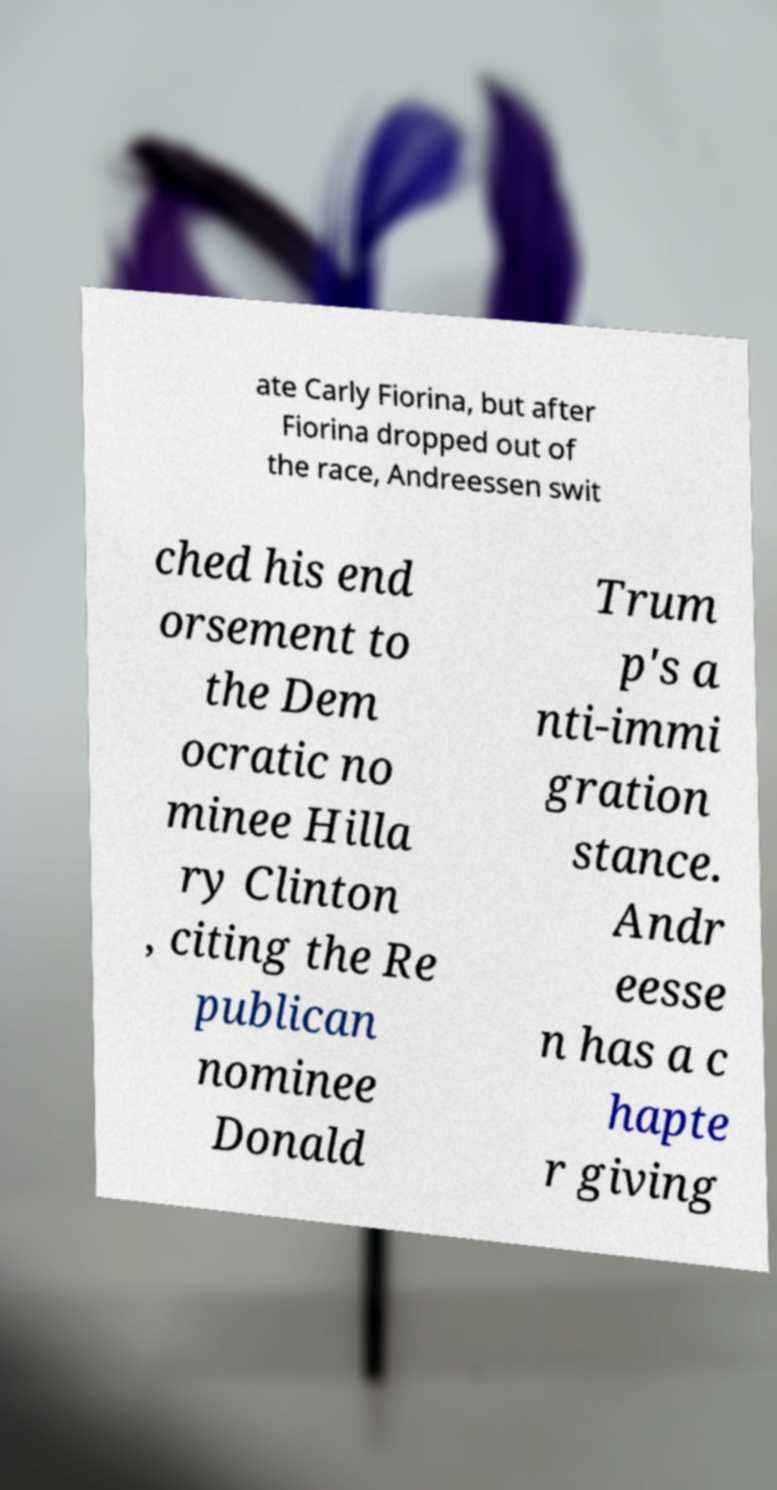Can you read and provide the text displayed in the image?This photo seems to have some interesting text. Can you extract and type it out for me? ate Carly Fiorina, but after Fiorina dropped out of the race, Andreessen swit ched his end orsement to the Dem ocratic no minee Hilla ry Clinton , citing the Re publican nominee Donald Trum p's a nti-immi gration stance. Andr eesse n has a c hapte r giving 